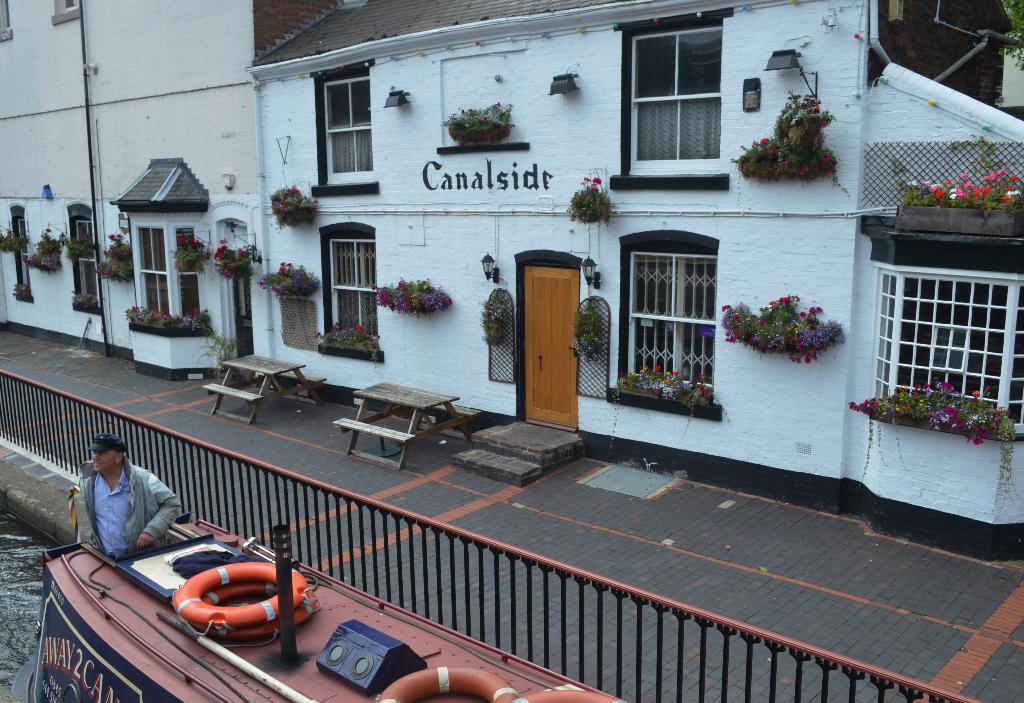Could you give a brief overview of what you see in this image? In this picture there is a person standing in an object and there is a fence beside him and there are few buildings which has few plants on it and there is a table in front of a building. 